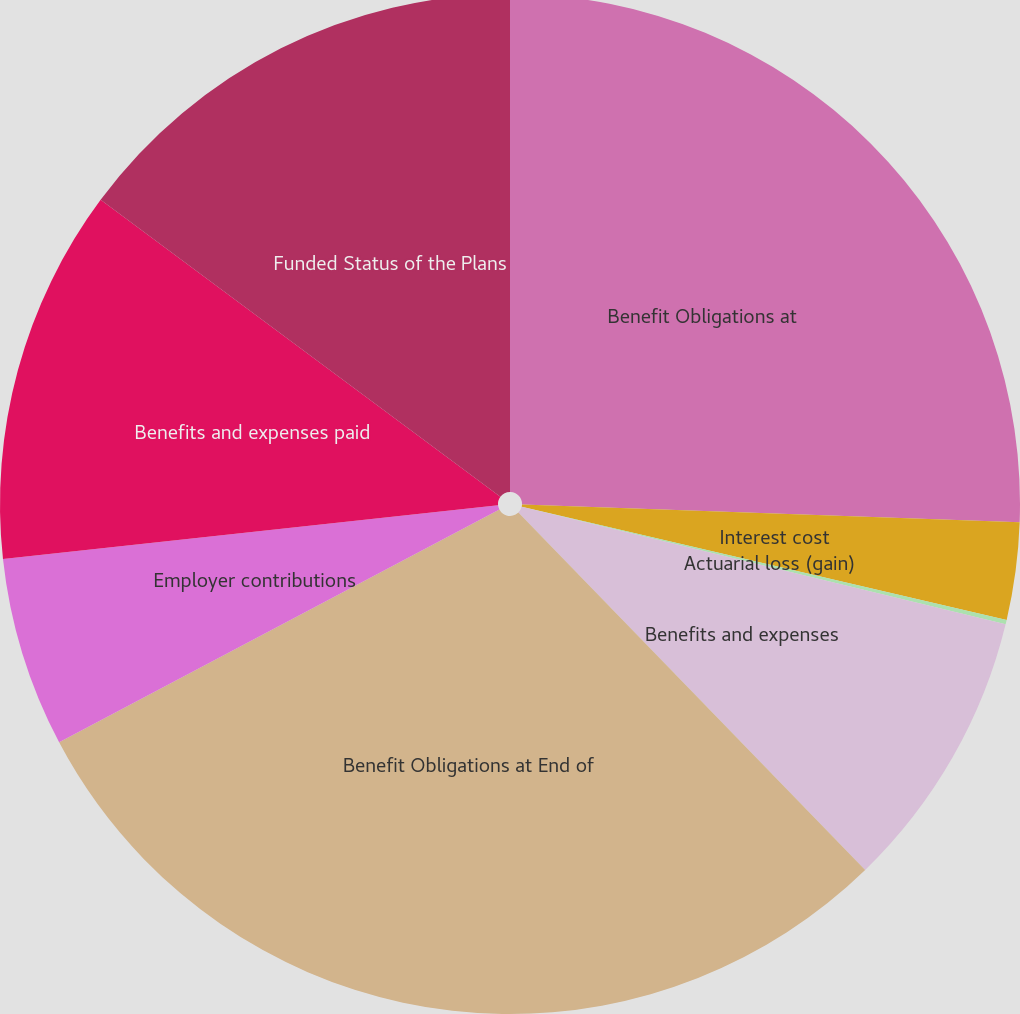<chart> <loc_0><loc_0><loc_500><loc_500><pie_chart><fcel>Benefit Obligations at<fcel>Interest cost<fcel>Actuarial loss (gain)<fcel>Benefits and expenses<fcel>Benefit Obligations at End of<fcel>Employer contributions<fcel>Benefits and expenses paid<fcel>Funded Status of the Plans<nl><fcel>25.57%<fcel>3.08%<fcel>0.14%<fcel>8.95%<fcel>29.52%<fcel>6.02%<fcel>11.89%<fcel>14.83%<nl></chart> 